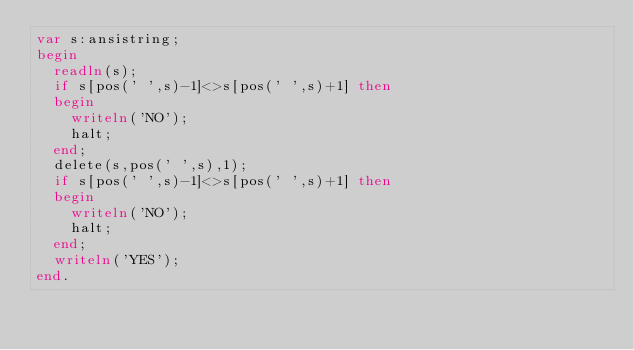<code> <loc_0><loc_0><loc_500><loc_500><_Pascal_>var s:ansistring;
begin
  readln(s);
  if s[pos(' ',s)-1]<>s[pos(' ',s)+1] then
  begin
    writeln('NO');
    halt;
  end;
  delete(s,pos(' ',s),1);
  if s[pos(' ',s)-1]<>s[pos(' ',s)+1] then
  begin
    writeln('NO');
    halt;
  end;
  writeln('YES');
end.</code> 